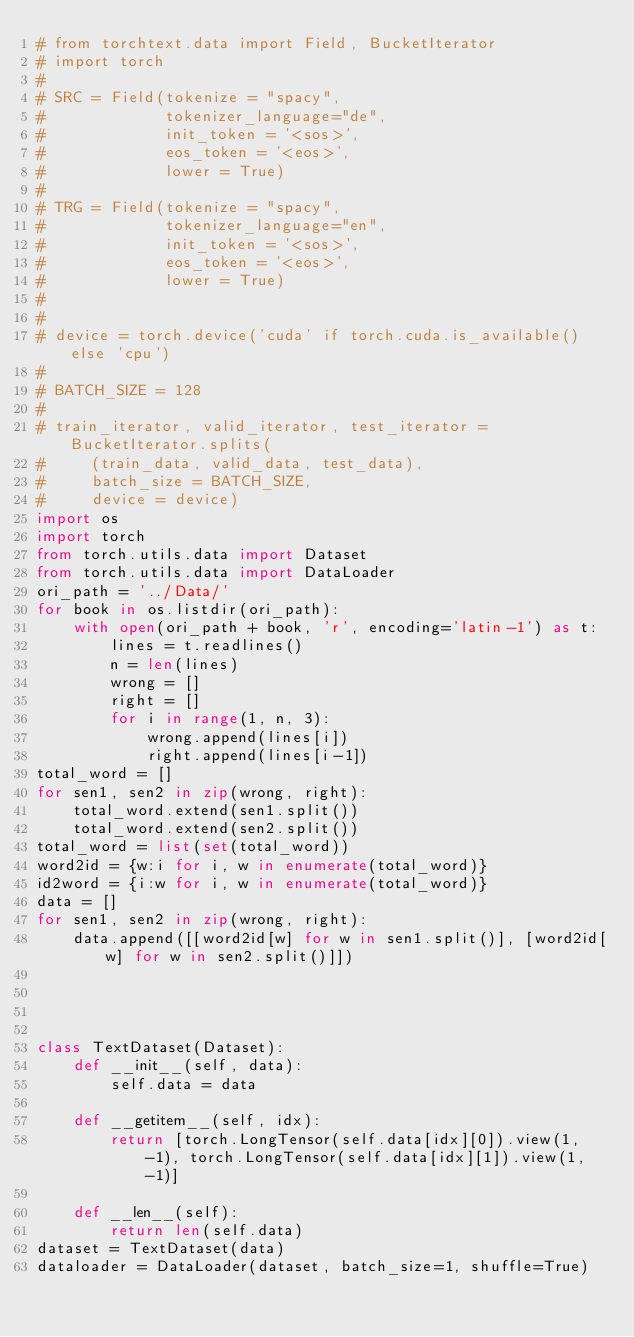Convert code to text. <code><loc_0><loc_0><loc_500><loc_500><_Python_># from torchtext.data import Field, BucketIterator
# import torch
#
# SRC = Field(tokenize = "spacy",
#             tokenizer_language="de",
#             init_token = '<sos>',
#             eos_token = '<eos>',
#             lower = True)
#
# TRG = Field(tokenize = "spacy",
#             tokenizer_language="en",
#             init_token = '<sos>',
#             eos_token = '<eos>',
#             lower = True)
#
#
# device = torch.device('cuda' if torch.cuda.is_available() else 'cpu')
#
# BATCH_SIZE = 128
#
# train_iterator, valid_iterator, test_iterator = BucketIterator.splits(
#     (train_data, valid_data, test_data),
#     batch_size = BATCH_SIZE,
#     device = device)
import os
import torch
from torch.utils.data import Dataset
from torch.utils.data import DataLoader
ori_path = '../Data/'
for book in os.listdir(ori_path):
    with open(ori_path + book, 'r', encoding='latin-1') as t:
        lines = t.readlines()
        n = len(lines)
        wrong = []
        right = []
        for i in range(1, n, 3):
            wrong.append(lines[i])
            right.append(lines[i-1])
total_word = []
for sen1, sen2 in zip(wrong, right):
    total_word.extend(sen1.split())
    total_word.extend(sen2.split())
total_word = list(set(total_word))
word2id = {w:i for i, w in enumerate(total_word)}
id2word = {i:w for i, w in enumerate(total_word)}
data = []
for sen1, sen2 in zip(wrong, right):
    data.append([[word2id[w] for w in sen1.split()], [word2id[w] for w in sen2.split()]])




class TextDataset(Dataset):
    def __init__(self, data):
        self.data = data

    def __getitem__(self, idx):
        return [torch.LongTensor(self.data[idx][0]).view(1, -1), torch.LongTensor(self.data[idx][1]).view(1, -1)]

    def __len__(self):
        return len(self.data)
dataset = TextDataset(data)
dataloader = DataLoader(dataset, batch_size=1, shuffle=True)

</code> 